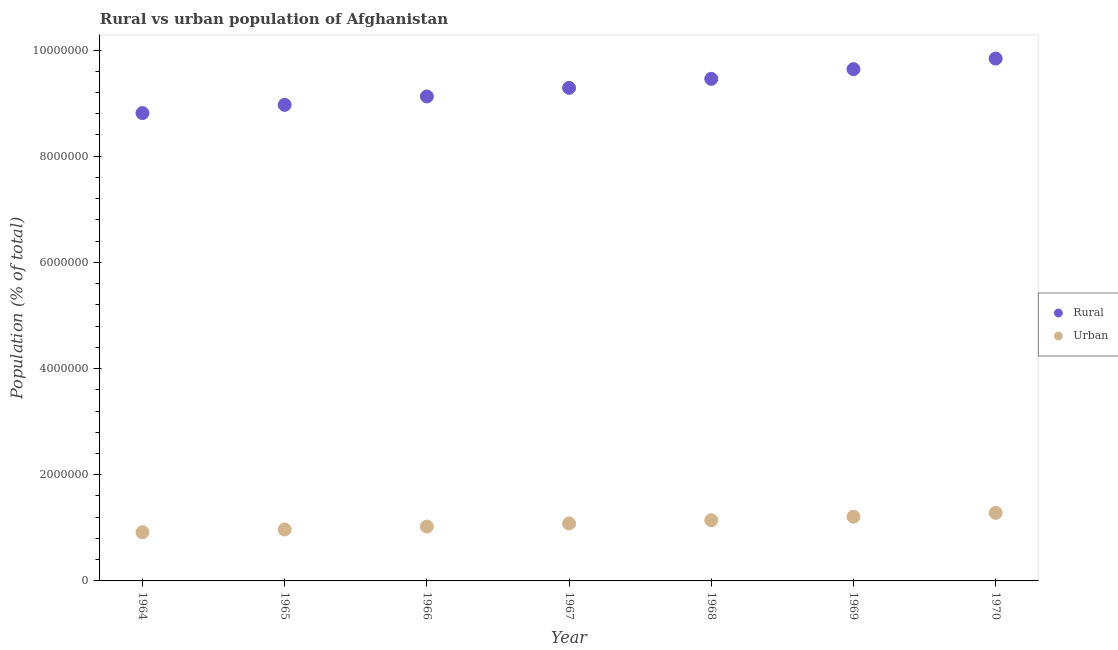How many different coloured dotlines are there?
Give a very brief answer. 2. Is the number of dotlines equal to the number of legend labels?
Your answer should be very brief. Yes. What is the rural population density in 1966?
Your response must be concise. 9.13e+06. Across all years, what is the maximum urban population density?
Your response must be concise. 1.28e+06. Across all years, what is the minimum rural population density?
Your answer should be compact. 8.81e+06. In which year was the rural population density maximum?
Give a very brief answer. 1970. In which year was the rural population density minimum?
Ensure brevity in your answer.  1964. What is the total urban population density in the graph?
Your response must be concise. 7.63e+06. What is the difference between the rural population density in 1965 and that in 1968?
Keep it short and to the point. -4.90e+05. What is the difference between the urban population density in 1969 and the rural population density in 1965?
Your response must be concise. -7.76e+06. What is the average urban population density per year?
Offer a terse response. 1.09e+06. In the year 1969, what is the difference between the rural population density and urban population density?
Offer a terse response. 8.43e+06. In how many years, is the rural population density greater than 1600000 %?
Your answer should be very brief. 7. What is the ratio of the urban population density in 1967 to that in 1969?
Make the answer very short. 0.89. Is the rural population density in 1967 less than that in 1968?
Your response must be concise. Yes. What is the difference between the highest and the second highest rural population density?
Keep it short and to the point. 1.99e+05. What is the difference between the highest and the lowest rural population density?
Your answer should be compact. 1.03e+06. In how many years, is the rural population density greater than the average rural population density taken over all years?
Provide a short and direct response. 3. Is the sum of the urban population density in 1965 and 1969 greater than the maximum rural population density across all years?
Make the answer very short. No. Is the rural population density strictly less than the urban population density over the years?
Ensure brevity in your answer.  No. How many dotlines are there?
Your answer should be compact. 2. What is the difference between two consecutive major ticks on the Y-axis?
Provide a succinct answer. 2.00e+06. Are the values on the major ticks of Y-axis written in scientific E-notation?
Your answer should be compact. No. How many legend labels are there?
Offer a terse response. 2. What is the title of the graph?
Your response must be concise. Rural vs urban population of Afghanistan. Does "All education staff compensation" appear as one of the legend labels in the graph?
Your response must be concise. No. What is the label or title of the Y-axis?
Give a very brief answer. Population (% of total). What is the Population (% of total) of Rural in 1964?
Your answer should be very brief. 8.81e+06. What is the Population (% of total) of Urban in 1964?
Your answer should be compact. 9.17e+05. What is the Population (% of total) in Rural in 1965?
Offer a very short reply. 8.97e+06. What is the Population (% of total) of Urban in 1965?
Provide a succinct answer. 9.69e+05. What is the Population (% of total) in Rural in 1966?
Keep it short and to the point. 9.13e+06. What is the Population (% of total) in Urban in 1966?
Provide a succinct answer. 1.02e+06. What is the Population (% of total) in Rural in 1967?
Keep it short and to the point. 9.29e+06. What is the Population (% of total) of Urban in 1967?
Keep it short and to the point. 1.08e+06. What is the Population (% of total) in Rural in 1968?
Your answer should be compact. 9.46e+06. What is the Population (% of total) in Urban in 1968?
Offer a terse response. 1.14e+06. What is the Population (% of total) of Rural in 1969?
Ensure brevity in your answer.  9.64e+06. What is the Population (% of total) of Urban in 1969?
Your answer should be very brief. 1.21e+06. What is the Population (% of total) in Rural in 1970?
Keep it short and to the point. 9.84e+06. What is the Population (% of total) in Urban in 1970?
Make the answer very short. 1.28e+06. Across all years, what is the maximum Population (% of total) of Rural?
Make the answer very short. 9.84e+06. Across all years, what is the maximum Population (% of total) of Urban?
Your answer should be compact. 1.28e+06. Across all years, what is the minimum Population (% of total) of Rural?
Your answer should be compact. 8.81e+06. Across all years, what is the minimum Population (% of total) in Urban?
Keep it short and to the point. 9.17e+05. What is the total Population (% of total) of Rural in the graph?
Offer a terse response. 6.51e+07. What is the total Population (% of total) in Urban in the graph?
Your answer should be very brief. 7.63e+06. What is the difference between the Population (% of total) of Rural in 1964 and that in 1965?
Keep it short and to the point. -1.55e+05. What is the difference between the Population (% of total) in Urban in 1964 and that in 1965?
Your answer should be compact. -5.17e+04. What is the difference between the Population (% of total) of Rural in 1964 and that in 1966?
Ensure brevity in your answer.  -3.14e+05. What is the difference between the Population (% of total) in Urban in 1964 and that in 1966?
Ensure brevity in your answer.  -1.06e+05. What is the difference between the Population (% of total) of Rural in 1964 and that in 1967?
Give a very brief answer. -4.76e+05. What is the difference between the Population (% of total) in Urban in 1964 and that in 1967?
Ensure brevity in your answer.  -1.64e+05. What is the difference between the Population (% of total) in Rural in 1964 and that in 1968?
Keep it short and to the point. -6.45e+05. What is the difference between the Population (% of total) in Urban in 1964 and that in 1968?
Your answer should be very brief. -2.26e+05. What is the difference between the Population (% of total) of Rural in 1964 and that in 1969?
Ensure brevity in your answer.  -8.28e+05. What is the difference between the Population (% of total) in Urban in 1964 and that in 1969?
Your answer should be very brief. -2.93e+05. What is the difference between the Population (% of total) in Rural in 1964 and that in 1970?
Give a very brief answer. -1.03e+06. What is the difference between the Population (% of total) of Urban in 1964 and that in 1970?
Give a very brief answer. -3.65e+05. What is the difference between the Population (% of total) of Rural in 1965 and that in 1966?
Your answer should be very brief. -1.59e+05. What is the difference between the Population (% of total) in Urban in 1965 and that in 1966?
Your answer should be compact. -5.48e+04. What is the difference between the Population (% of total) of Rural in 1965 and that in 1967?
Provide a short and direct response. -3.20e+05. What is the difference between the Population (% of total) in Urban in 1965 and that in 1967?
Your response must be concise. -1.13e+05. What is the difference between the Population (% of total) of Rural in 1965 and that in 1968?
Offer a very short reply. -4.90e+05. What is the difference between the Population (% of total) of Urban in 1965 and that in 1968?
Your answer should be very brief. -1.75e+05. What is the difference between the Population (% of total) in Rural in 1965 and that in 1969?
Give a very brief answer. -6.73e+05. What is the difference between the Population (% of total) of Urban in 1965 and that in 1969?
Provide a short and direct response. -2.41e+05. What is the difference between the Population (% of total) in Rural in 1965 and that in 1970?
Ensure brevity in your answer.  -8.72e+05. What is the difference between the Population (% of total) of Urban in 1965 and that in 1970?
Your response must be concise. -3.13e+05. What is the difference between the Population (% of total) of Rural in 1966 and that in 1967?
Keep it short and to the point. -1.62e+05. What is the difference between the Population (% of total) of Urban in 1966 and that in 1967?
Your response must be concise. -5.79e+04. What is the difference between the Population (% of total) of Rural in 1966 and that in 1968?
Your response must be concise. -3.31e+05. What is the difference between the Population (% of total) in Urban in 1966 and that in 1968?
Give a very brief answer. -1.20e+05. What is the difference between the Population (% of total) of Rural in 1966 and that in 1969?
Offer a very short reply. -5.14e+05. What is the difference between the Population (% of total) in Urban in 1966 and that in 1969?
Your answer should be very brief. -1.86e+05. What is the difference between the Population (% of total) in Rural in 1966 and that in 1970?
Offer a terse response. -7.14e+05. What is the difference between the Population (% of total) of Urban in 1966 and that in 1970?
Your answer should be compact. -2.59e+05. What is the difference between the Population (% of total) of Rural in 1967 and that in 1968?
Offer a very short reply. -1.69e+05. What is the difference between the Population (% of total) of Urban in 1967 and that in 1968?
Make the answer very short. -6.18e+04. What is the difference between the Population (% of total) of Rural in 1967 and that in 1969?
Make the answer very short. -3.52e+05. What is the difference between the Population (% of total) in Urban in 1967 and that in 1969?
Give a very brief answer. -1.28e+05. What is the difference between the Population (% of total) in Rural in 1967 and that in 1970?
Your answer should be compact. -5.52e+05. What is the difference between the Population (% of total) of Urban in 1967 and that in 1970?
Make the answer very short. -2.01e+05. What is the difference between the Population (% of total) of Rural in 1968 and that in 1969?
Your answer should be very brief. -1.83e+05. What is the difference between the Population (% of total) in Urban in 1968 and that in 1969?
Keep it short and to the point. -6.66e+04. What is the difference between the Population (% of total) of Rural in 1968 and that in 1970?
Make the answer very short. -3.82e+05. What is the difference between the Population (% of total) in Urban in 1968 and that in 1970?
Offer a terse response. -1.39e+05. What is the difference between the Population (% of total) in Rural in 1969 and that in 1970?
Provide a succinct answer. -1.99e+05. What is the difference between the Population (% of total) in Urban in 1969 and that in 1970?
Your answer should be very brief. -7.22e+04. What is the difference between the Population (% of total) of Rural in 1964 and the Population (% of total) of Urban in 1965?
Your answer should be compact. 7.84e+06. What is the difference between the Population (% of total) of Rural in 1964 and the Population (% of total) of Urban in 1966?
Your answer should be very brief. 7.79e+06. What is the difference between the Population (% of total) in Rural in 1964 and the Population (% of total) in Urban in 1967?
Offer a terse response. 7.73e+06. What is the difference between the Population (% of total) in Rural in 1964 and the Population (% of total) in Urban in 1968?
Ensure brevity in your answer.  7.67e+06. What is the difference between the Population (% of total) of Rural in 1964 and the Population (% of total) of Urban in 1969?
Provide a succinct answer. 7.60e+06. What is the difference between the Population (% of total) in Rural in 1964 and the Population (% of total) in Urban in 1970?
Your answer should be compact. 7.53e+06. What is the difference between the Population (% of total) in Rural in 1965 and the Population (% of total) in Urban in 1966?
Keep it short and to the point. 7.94e+06. What is the difference between the Population (% of total) in Rural in 1965 and the Population (% of total) in Urban in 1967?
Provide a succinct answer. 7.89e+06. What is the difference between the Population (% of total) of Rural in 1965 and the Population (% of total) of Urban in 1968?
Offer a terse response. 7.82e+06. What is the difference between the Population (% of total) of Rural in 1965 and the Population (% of total) of Urban in 1969?
Give a very brief answer. 7.76e+06. What is the difference between the Population (% of total) of Rural in 1965 and the Population (% of total) of Urban in 1970?
Your answer should be very brief. 7.68e+06. What is the difference between the Population (% of total) of Rural in 1966 and the Population (% of total) of Urban in 1967?
Your answer should be very brief. 8.04e+06. What is the difference between the Population (% of total) in Rural in 1966 and the Population (% of total) in Urban in 1968?
Give a very brief answer. 7.98e+06. What is the difference between the Population (% of total) of Rural in 1966 and the Population (% of total) of Urban in 1969?
Offer a terse response. 7.92e+06. What is the difference between the Population (% of total) of Rural in 1966 and the Population (% of total) of Urban in 1970?
Your answer should be compact. 7.84e+06. What is the difference between the Population (% of total) of Rural in 1967 and the Population (% of total) of Urban in 1968?
Provide a short and direct response. 8.14e+06. What is the difference between the Population (% of total) in Rural in 1967 and the Population (% of total) in Urban in 1969?
Keep it short and to the point. 8.08e+06. What is the difference between the Population (% of total) of Rural in 1967 and the Population (% of total) of Urban in 1970?
Your response must be concise. 8.01e+06. What is the difference between the Population (% of total) in Rural in 1968 and the Population (% of total) in Urban in 1969?
Your response must be concise. 8.25e+06. What is the difference between the Population (% of total) of Rural in 1968 and the Population (% of total) of Urban in 1970?
Your answer should be very brief. 8.17e+06. What is the difference between the Population (% of total) in Rural in 1969 and the Population (% of total) in Urban in 1970?
Provide a short and direct response. 8.36e+06. What is the average Population (% of total) in Rural per year?
Provide a short and direct response. 9.30e+06. What is the average Population (% of total) in Urban per year?
Ensure brevity in your answer.  1.09e+06. In the year 1964, what is the difference between the Population (% of total) in Rural and Population (% of total) in Urban?
Offer a terse response. 7.89e+06. In the year 1965, what is the difference between the Population (% of total) of Rural and Population (% of total) of Urban?
Your answer should be very brief. 8.00e+06. In the year 1966, what is the difference between the Population (% of total) in Rural and Population (% of total) in Urban?
Ensure brevity in your answer.  8.10e+06. In the year 1967, what is the difference between the Population (% of total) in Rural and Population (% of total) in Urban?
Ensure brevity in your answer.  8.21e+06. In the year 1968, what is the difference between the Population (% of total) of Rural and Population (% of total) of Urban?
Make the answer very short. 8.31e+06. In the year 1969, what is the difference between the Population (% of total) in Rural and Population (% of total) in Urban?
Provide a short and direct response. 8.43e+06. In the year 1970, what is the difference between the Population (% of total) in Rural and Population (% of total) in Urban?
Your answer should be compact. 8.56e+06. What is the ratio of the Population (% of total) in Rural in 1964 to that in 1965?
Make the answer very short. 0.98. What is the ratio of the Population (% of total) of Urban in 1964 to that in 1965?
Your response must be concise. 0.95. What is the ratio of the Population (% of total) in Rural in 1964 to that in 1966?
Offer a terse response. 0.97. What is the ratio of the Population (% of total) in Urban in 1964 to that in 1966?
Your response must be concise. 0.9. What is the ratio of the Population (% of total) in Rural in 1964 to that in 1967?
Keep it short and to the point. 0.95. What is the ratio of the Population (% of total) in Urban in 1964 to that in 1967?
Give a very brief answer. 0.85. What is the ratio of the Population (% of total) in Rural in 1964 to that in 1968?
Give a very brief answer. 0.93. What is the ratio of the Population (% of total) in Urban in 1964 to that in 1968?
Offer a very short reply. 0.8. What is the ratio of the Population (% of total) of Rural in 1964 to that in 1969?
Keep it short and to the point. 0.91. What is the ratio of the Population (% of total) of Urban in 1964 to that in 1969?
Provide a succinct answer. 0.76. What is the ratio of the Population (% of total) in Rural in 1964 to that in 1970?
Provide a short and direct response. 0.9. What is the ratio of the Population (% of total) of Urban in 1964 to that in 1970?
Your answer should be very brief. 0.72. What is the ratio of the Population (% of total) in Rural in 1965 to that in 1966?
Provide a succinct answer. 0.98. What is the ratio of the Population (% of total) of Urban in 1965 to that in 1966?
Give a very brief answer. 0.95. What is the ratio of the Population (% of total) of Rural in 1965 to that in 1967?
Make the answer very short. 0.97. What is the ratio of the Population (% of total) of Urban in 1965 to that in 1967?
Your answer should be very brief. 0.9. What is the ratio of the Population (% of total) of Rural in 1965 to that in 1968?
Give a very brief answer. 0.95. What is the ratio of the Population (% of total) of Urban in 1965 to that in 1968?
Give a very brief answer. 0.85. What is the ratio of the Population (% of total) of Rural in 1965 to that in 1969?
Make the answer very short. 0.93. What is the ratio of the Population (% of total) in Urban in 1965 to that in 1969?
Keep it short and to the point. 0.8. What is the ratio of the Population (% of total) of Rural in 1965 to that in 1970?
Your answer should be compact. 0.91. What is the ratio of the Population (% of total) in Urban in 1965 to that in 1970?
Your answer should be very brief. 0.76. What is the ratio of the Population (% of total) of Rural in 1966 to that in 1967?
Your answer should be compact. 0.98. What is the ratio of the Population (% of total) of Urban in 1966 to that in 1967?
Your response must be concise. 0.95. What is the ratio of the Population (% of total) of Urban in 1966 to that in 1968?
Keep it short and to the point. 0.9. What is the ratio of the Population (% of total) of Rural in 1966 to that in 1969?
Ensure brevity in your answer.  0.95. What is the ratio of the Population (% of total) in Urban in 1966 to that in 1969?
Keep it short and to the point. 0.85. What is the ratio of the Population (% of total) in Rural in 1966 to that in 1970?
Give a very brief answer. 0.93. What is the ratio of the Population (% of total) of Urban in 1966 to that in 1970?
Provide a succinct answer. 0.8. What is the ratio of the Population (% of total) in Rural in 1967 to that in 1968?
Keep it short and to the point. 0.98. What is the ratio of the Population (% of total) of Urban in 1967 to that in 1968?
Your answer should be very brief. 0.95. What is the ratio of the Population (% of total) of Rural in 1967 to that in 1969?
Give a very brief answer. 0.96. What is the ratio of the Population (% of total) of Urban in 1967 to that in 1969?
Keep it short and to the point. 0.89. What is the ratio of the Population (% of total) in Rural in 1967 to that in 1970?
Make the answer very short. 0.94. What is the ratio of the Population (% of total) of Urban in 1967 to that in 1970?
Keep it short and to the point. 0.84. What is the ratio of the Population (% of total) in Rural in 1968 to that in 1969?
Your answer should be very brief. 0.98. What is the ratio of the Population (% of total) of Urban in 1968 to that in 1969?
Provide a short and direct response. 0.94. What is the ratio of the Population (% of total) in Rural in 1968 to that in 1970?
Your answer should be very brief. 0.96. What is the ratio of the Population (% of total) in Urban in 1968 to that in 1970?
Your answer should be compact. 0.89. What is the ratio of the Population (% of total) in Rural in 1969 to that in 1970?
Offer a terse response. 0.98. What is the ratio of the Population (% of total) in Urban in 1969 to that in 1970?
Keep it short and to the point. 0.94. What is the difference between the highest and the second highest Population (% of total) in Rural?
Your response must be concise. 1.99e+05. What is the difference between the highest and the second highest Population (% of total) of Urban?
Keep it short and to the point. 7.22e+04. What is the difference between the highest and the lowest Population (% of total) in Rural?
Offer a very short reply. 1.03e+06. What is the difference between the highest and the lowest Population (% of total) of Urban?
Your answer should be very brief. 3.65e+05. 